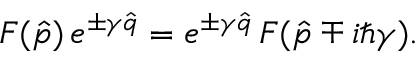Convert formula to latex. <formula><loc_0><loc_0><loc_500><loc_500>F ( \hat { p } ) \, e ^ { \pm \gamma \hat { q } } = e ^ { \pm \gamma \hat { q } } \, F ( \hat { p } \mp i \hbar { \gamma } ) .</formula> 